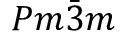<formula> <loc_0><loc_0><loc_500><loc_500>P m \ B a r { 3 } m</formula> 